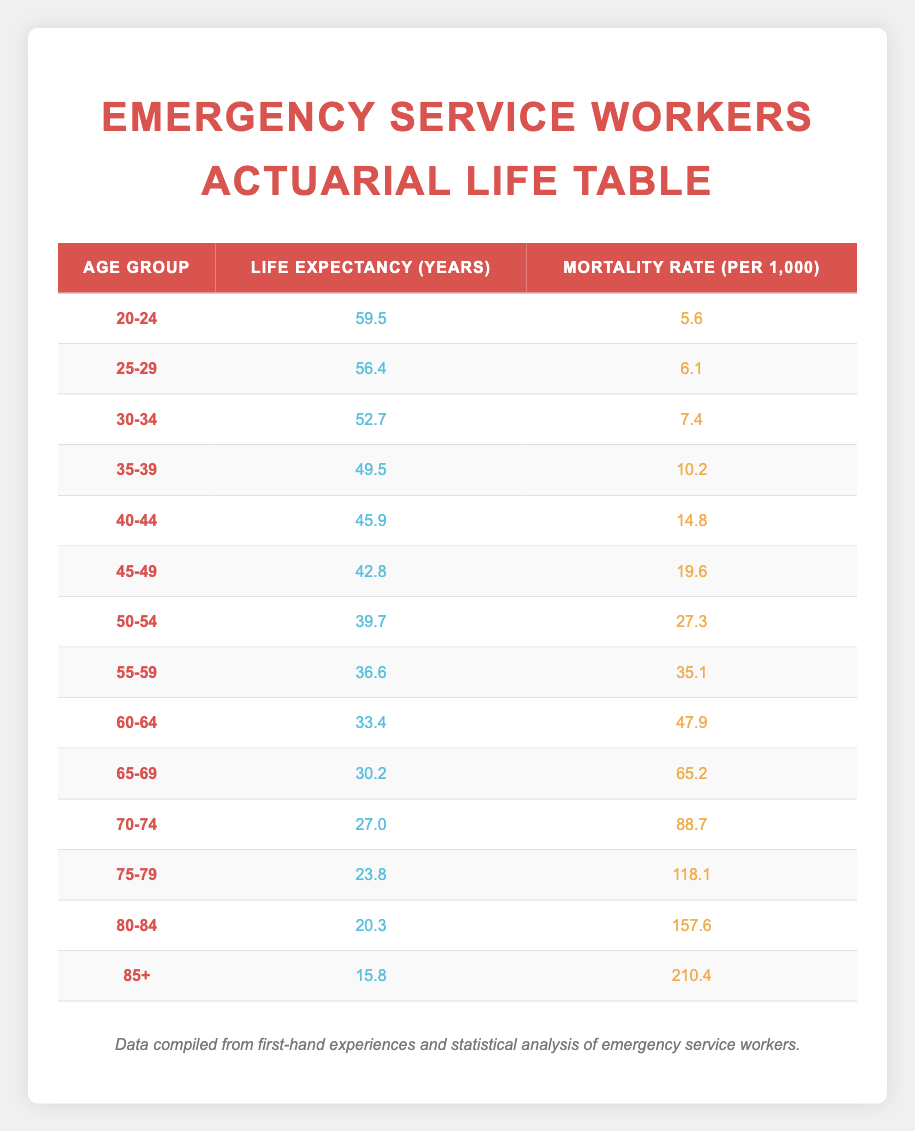What is the life expectancy for emergency service workers aged 40-44? The life expectancy for the age group 40-44 is directly listed in the table under the corresponding row. It shows the value as 45.9 years.
Answer: 45.9 What is the mortality rate for emergency service workers aged 55-59? The mortality rate for the age group 55-59 can be found in the corresponding row of the table. The value is 35.1 per 1000.
Answer: 35.1 Which age group has the highest mortality rate? By examining the table, the row with the age group 85+ shows the mortality rate of 210.4 per 1000, which is the highest value listed.
Answer: 85+ What is the difference in life expectancy between the age groups 30-34 and 50-54? The life expectancy for 30-34 is 52.7 years, while for 50-54 it is 39.7 years. Therefore, the difference is calculated as 52.7 - 39.7 = 13.0 years.
Answer: 13.0 Is the mortality rate for the age group 65-69 greater than 60? The mortality rate for 65-69 is 65.2 per 1000, which is indeed greater than 60, thus this statement is true.
Answer: Yes What is the average life expectancy for emergency service workers aged 30-34 and 40-44? The life expectancy for 30-34 is 52.7 years, and for 40-44 it is 45.9 years. The average is calculated by summing these two values and dividing by 2: (52.7 + 45.9) / 2 = 48.3 years.
Answer: 48.3 Which age group has a life expectancy lower than 30 years? The age groups listed in the table are 20-24, 25-29, 30-34, 35-39, 40-44, 45-49, 50-54, 55-59, 60-64, 65-69, 70-74, 75-79, 80-84, and 85+. The only group with a life expectancy lower than 30 years is 85+, which has a life expectancy of 15.8 years.
Answer: 85+ How much does the life expectancy decrease from the age group 70-74 to the age group 75-79? The life expectancy for 70-74 is 27.0 years, and for 75-79 it is 23.8 years. The decrease is calculated as 27.0 - 23.8 = 3.2 years.
Answer: 3.2 